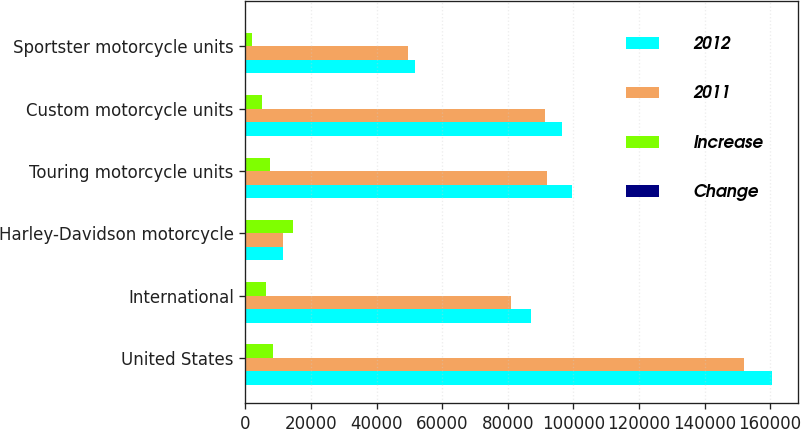<chart> <loc_0><loc_0><loc_500><loc_500><stacked_bar_chart><ecel><fcel>United States<fcel>International<fcel>Harley-Davidson motorcycle<fcel>Touring motorcycle units<fcel>Custom motorcycle units<fcel>Sportster motorcycle units<nl><fcel>2012<fcel>160477<fcel>87148<fcel>11402.5<fcel>99496<fcel>96425<fcel>51704<nl><fcel>2011<fcel>152180<fcel>80937<fcel>11402.5<fcel>92002<fcel>91459<fcel>49656<nl><fcel>Increase<fcel>8297<fcel>6211<fcel>14508<fcel>7494<fcel>4966<fcel>2048<nl><fcel>Change<fcel>5.5<fcel>7.7<fcel>6.2<fcel>8.1<fcel>5.4<fcel>4.1<nl></chart> 